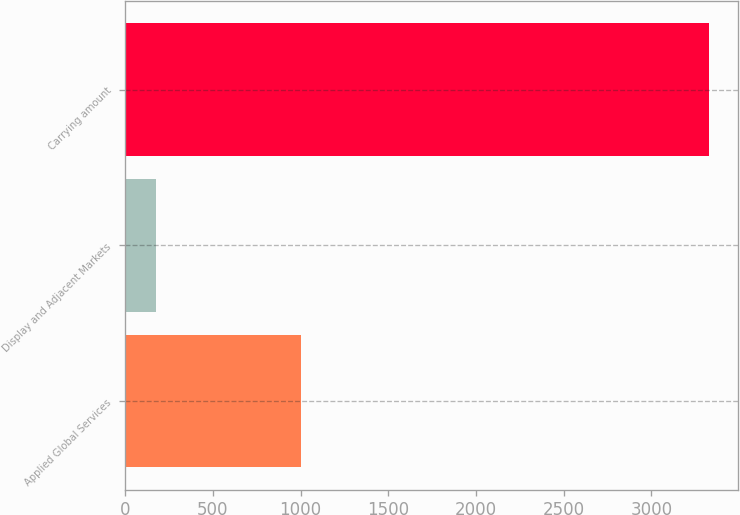Convert chart. <chart><loc_0><loc_0><loc_500><loc_500><bar_chart><fcel>Applied Global Services<fcel>Display and Adjacent Markets<fcel>Carrying amount<nl><fcel>1001<fcel>175<fcel>3327<nl></chart> 